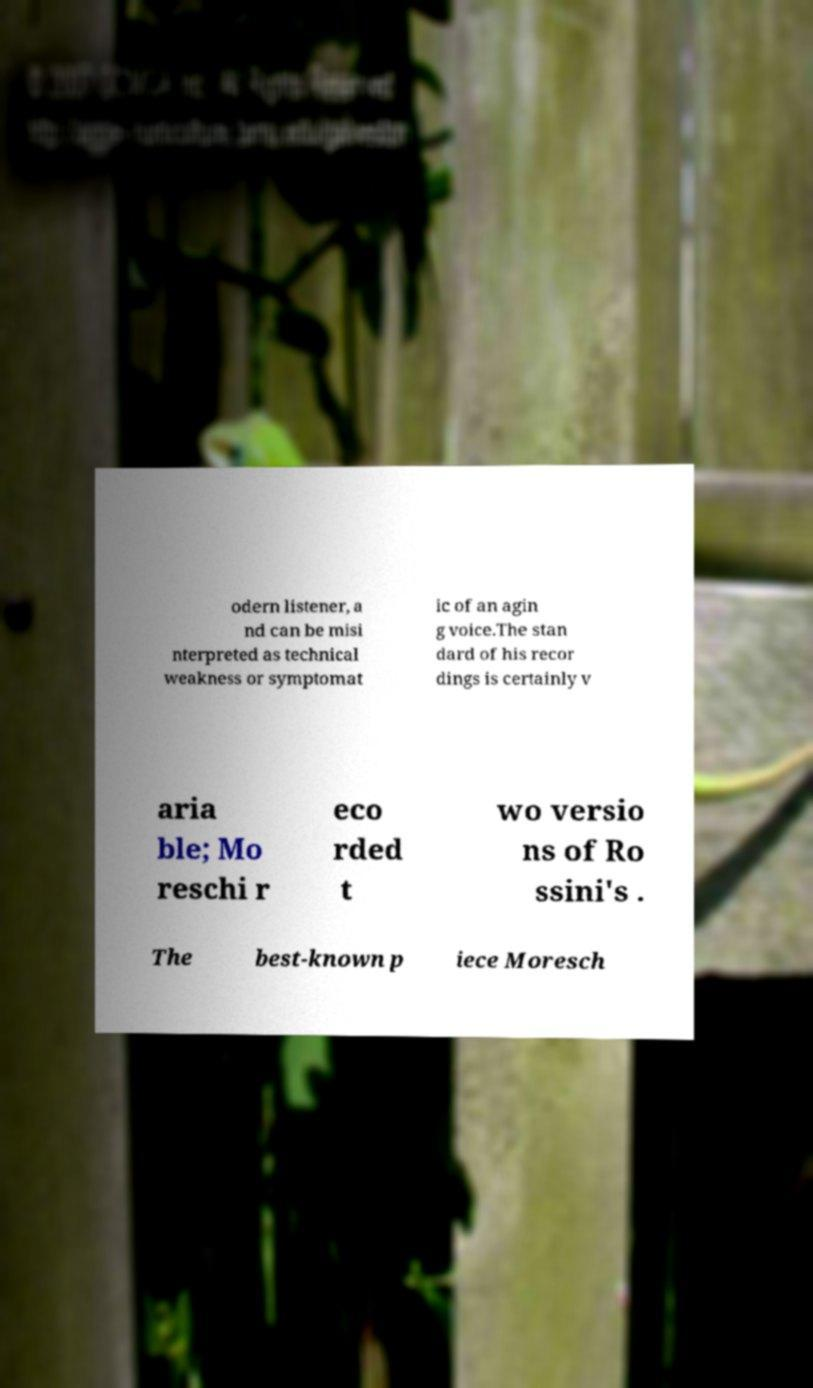Please read and relay the text visible in this image. What does it say? odern listener, a nd can be misi nterpreted as technical weakness or symptomat ic of an agin g voice.The stan dard of his recor dings is certainly v aria ble; Mo reschi r eco rded t wo versio ns of Ro ssini's . The best-known p iece Moresch 